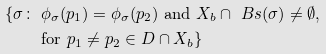Convert formula to latex. <formula><loc_0><loc_0><loc_500><loc_500>\{ \sigma \colon & \ \phi _ { \sigma } ( p _ { 1 } ) = \phi _ { \sigma } ( p _ { 2 } ) \text { and } X _ { b } \cap \ B s ( \sigma ) \ne \emptyset , \\ & \text { for } p _ { 1 } \ne p _ { 2 } \in D \cap X _ { b } \}</formula> 